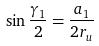Convert formula to latex. <formula><loc_0><loc_0><loc_500><loc_500>\sin \frac { \gamma _ { 1 } } { 2 } = \frac { a _ { 1 } } { 2 r _ { u } }</formula> 